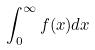<formula> <loc_0><loc_0><loc_500><loc_500>\int _ { 0 } ^ { \infty } f ( x ) d x</formula> 